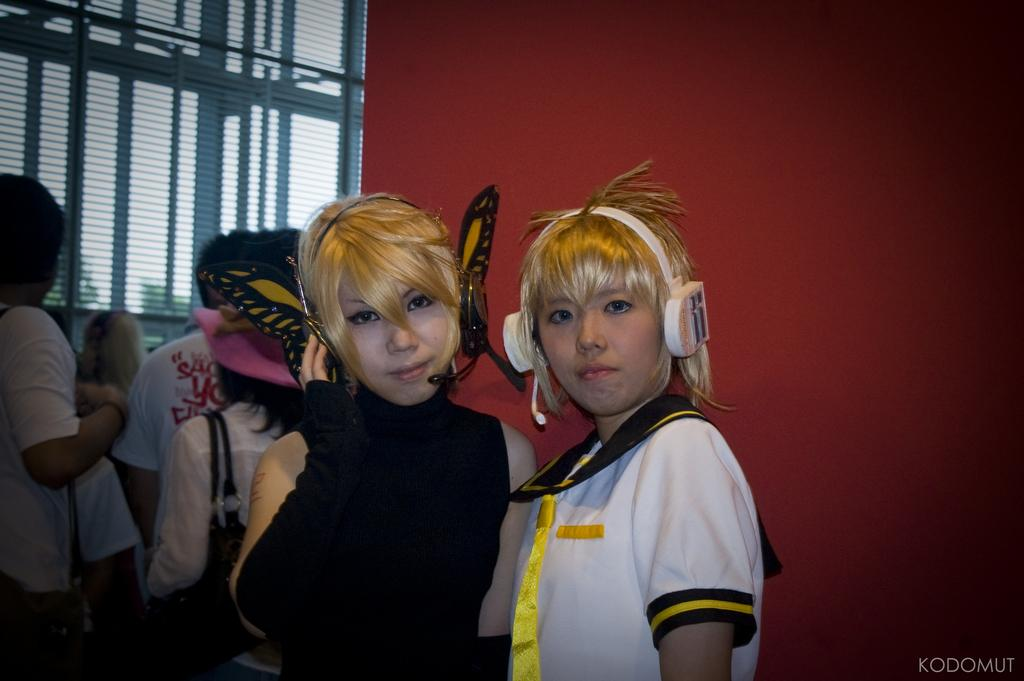How many women are in the image? There are two women in the image. What are the women wearing on their heads? The women are wearing headsets. Can you describe the background of the image? There are people and a wall visible in the background of the image. What type of pear is being stitched by the women in the image? There is no pear or stitching activity present in the image; the women are wearing headsets. 